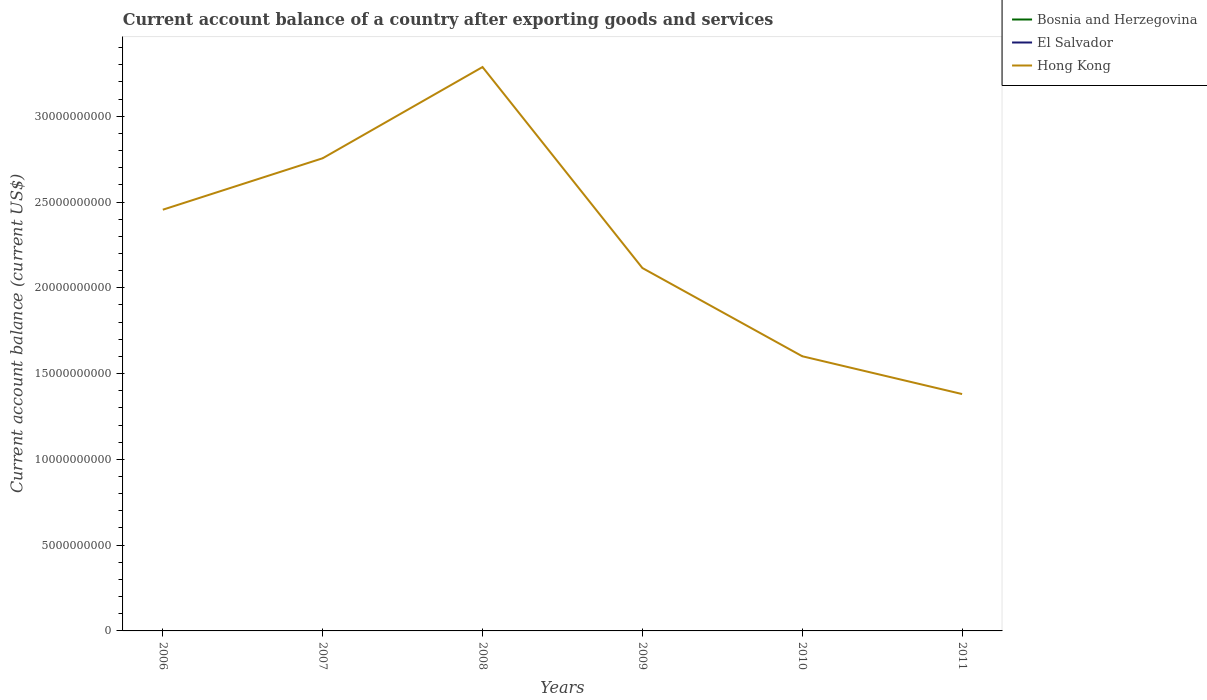Is the number of lines equal to the number of legend labels?
Ensure brevity in your answer.  No. Across all years, what is the maximum account balance in Hong Kong?
Make the answer very short. 1.38e+1. What is the total account balance in Hong Kong in the graph?
Provide a succinct answer. -5.32e+09. What is the difference between the highest and the second highest account balance in Hong Kong?
Your response must be concise. 1.91e+1. Is the account balance in Hong Kong strictly greater than the account balance in El Salvador over the years?
Make the answer very short. No. Are the values on the major ticks of Y-axis written in scientific E-notation?
Give a very brief answer. No. Does the graph contain any zero values?
Provide a short and direct response. Yes. Where does the legend appear in the graph?
Provide a succinct answer. Top right. How many legend labels are there?
Offer a terse response. 3. What is the title of the graph?
Your answer should be compact. Current account balance of a country after exporting goods and services. What is the label or title of the Y-axis?
Offer a very short reply. Current account balance (current US$). What is the Current account balance (current US$) of Bosnia and Herzegovina in 2006?
Make the answer very short. 0. What is the Current account balance (current US$) in Hong Kong in 2006?
Offer a terse response. 2.46e+1. What is the Current account balance (current US$) in Bosnia and Herzegovina in 2007?
Offer a very short reply. 0. What is the Current account balance (current US$) in El Salvador in 2007?
Give a very brief answer. 0. What is the Current account balance (current US$) in Hong Kong in 2007?
Your answer should be very brief. 2.76e+1. What is the Current account balance (current US$) of Hong Kong in 2008?
Ensure brevity in your answer.  3.29e+1. What is the Current account balance (current US$) of Hong Kong in 2009?
Make the answer very short. 2.12e+1. What is the Current account balance (current US$) in Bosnia and Herzegovina in 2010?
Your answer should be compact. 0. What is the Current account balance (current US$) of Hong Kong in 2010?
Give a very brief answer. 1.60e+1. What is the Current account balance (current US$) in Bosnia and Herzegovina in 2011?
Your answer should be very brief. 0. What is the Current account balance (current US$) in El Salvador in 2011?
Ensure brevity in your answer.  0. What is the Current account balance (current US$) of Hong Kong in 2011?
Make the answer very short. 1.38e+1. Across all years, what is the maximum Current account balance (current US$) of Hong Kong?
Ensure brevity in your answer.  3.29e+1. Across all years, what is the minimum Current account balance (current US$) in Hong Kong?
Your response must be concise. 1.38e+1. What is the total Current account balance (current US$) of El Salvador in the graph?
Your answer should be very brief. 0. What is the total Current account balance (current US$) in Hong Kong in the graph?
Make the answer very short. 1.36e+11. What is the difference between the Current account balance (current US$) of Hong Kong in 2006 and that in 2007?
Offer a terse response. -3.00e+09. What is the difference between the Current account balance (current US$) in Hong Kong in 2006 and that in 2008?
Offer a terse response. -8.32e+09. What is the difference between the Current account balance (current US$) in Hong Kong in 2006 and that in 2009?
Provide a short and direct response. 3.40e+09. What is the difference between the Current account balance (current US$) of Hong Kong in 2006 and that in 2010?
Provide a short and direct response. 8.54e+09. What is the difference between the Current account balance (current US$) in Hong Kong in 2006 and that in 2011?
Keep it short and to the point. 1.07e+1. What is the difference between the Current account balance (current US$) in Hong Kong in 2007 and that in 2008?
Your answer should be compact. -5.32e+09. What is the difference between the Current account balance (current US$) in Hong Kong in 2007 and that in 2009?
Give a very brief answer. 6.40e+09. What is the difference between the Current account balance (current US$) of Hong Kong in 2007 and that in 2010?
Offer a very short reply. 1.15e+1. What is the difference between the Current account balance (current US$) of Hong Kong in 2007 and that in 2011?
Your answer should be very brief. 1.37e+1. What is the difference between the Current account balance (current US$) in Hong Kong in 2008 and that in 2009?
Your answer should be compact. 1.17e+1. What is the difference between the Current account balance (current US$) in Hong Kong in 2008 and that in 2010?
Your answer should be compact. 1.69e+1. What is the difference between the Current account balance (current US$) in Hong Kong in 2008 and that in 2011?
Keep it short and to the point. 1.91e+1. What is the difference between the Current account balance (current US$) of Hong Kong in 2009 and that in 2010?
Give a very brief answer. 5.14e+09. What is the difference between the Current account balance (current US$) in Hong Kong in 2009 and that in 2011?
Offer a terse response. 7.35e+09. What is the difference between the Current account balance (current US$) of Hong Kong in 2010 and that in 2011?
Provide a succinct answer. 2.20e+09. What is the average Current account balance (current US$) of El Salvador per year?
Offer a terse response. 0. What is the average Current account balance (current US$) of Hong Kong per year?
Give a very brief answer. 2.27e+1. What is the ratio of the Current account balance (current US$) of Hong Kong in 2006 to that in 2007?
Make the answer very short. 0.89. What is the ratio of the Current account balance (current US$) in Hong Kong in 2006 to that in 2008?
Keep it short and to the point. 0.75. What is the ratio of the Current account balance (current US$) of Hong Kong in 2006 to that in 2009?
Keep it short and to the point. 1.16. What is the ratio of the Current account balance (current US$) in Hong Kong in 2006 to that in 2010?
Make the answer very short. 1.53. What is the ratio of the Current account balance (current US$) in Hong Kong in 2006 to that in 2011?
Your answer should be compact. 1.78. What is the ratio of the Current account balance (current US$) of Hong Kong in 2007 to that in 2008?
Your answer should be compact. 0.84. What is the ratio of the Current account balance (current US$) of Hong Kong in 2007 to that in 2009?
Your answer should be very brief. 1.3. What is the ratio of the Current account balance (current US$) of Hong Kong in 2007 to that in 2010?
Give a very brief answer. 1.72. What is the ratio of the Current account balance (current US$) in Hong Kong in 2007 to that in 2011?
Provide a short and direct response. 2. What is the ratio of the Current account balance (current US$) of Hong Kong in 2008 to that in 2009?
Your response must be concise. 1.55. What is the ratio of the Current account balance (current US$) in Hong Kong in 2008 to that in 2010?
Provide a succinct answer. 2.05. What is the ratio of the Current account balance (current US$) in Hong Kong in 2008 to that in 2011?
Offer a very short reply. 2.38. What is the ratio of the Current account balance (current US$) in Hong Kong in 2009 to that in 2010?
Provide a short and direct response. 1.32. What is the ratio of the Current account balance (current US$) in Hong Kong in 2009 to that in 2011?
Provide a short and direct response. 1.53. What is the ratio of the Current account balance (current US$) of Hong Kong in 2010 to that in 2011?
Make the answer very short. 1.16. What is the difference between the highest and the second highest Current account balance (current US$) in Hong Kong?
Give a very brief answer. 5.32e+09. What is the difference between the highest and the lowest Current account balance (current US$) of Hong Kong?
Your answer should be very brief. 1.91e+1. 